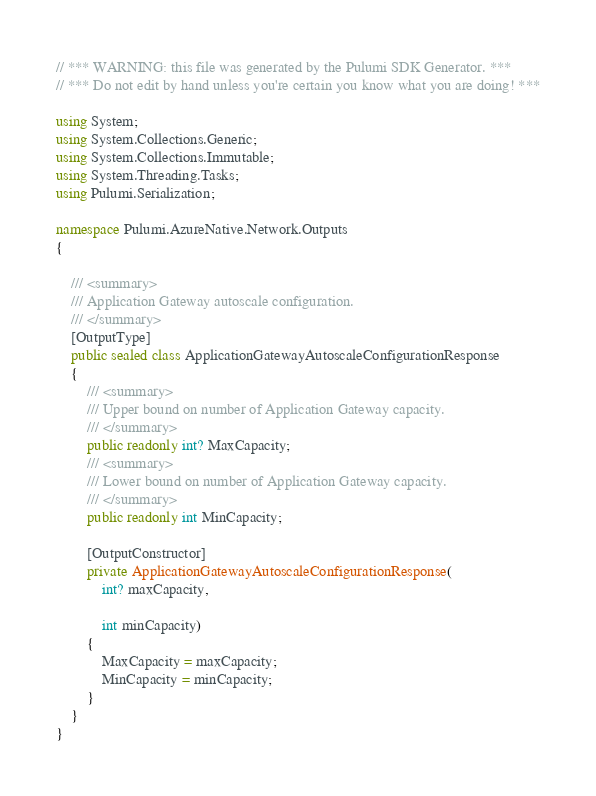Convert code to text. <code><loc_0><loc_0><loc_500><loc_500><_C#_>// *** WARNING: this file was generated by the Pulumi SDK Generator. ***
// *** Do not edit by hand unless you're certain you know what you are doing! ***

using System;
using System.Collections.Generic;
using System.Collections.Immutable;
using System.Threading.Tasks;
using Pulumi.Serialization;

namespace Pulumi.AzureNative.Network.Outputs
{

    /// <summary>
    /// Application Gateway autoscale configuration.
    /// </summary>
    [OutputType]
    public sealed class ApplicationGatewayAutoscaleConfigurationResponse
    {
        /// <summary>
        /// Upper bound on number of Application Gateway capacity.
        /// </summary>
        public readonly int? MaxCapacity;
        /// <summary>
        /// Lower bound on number of Application Gateway capacity.
        /// </summary>
        public readonly int MinCapacity;

        [OutputConstructor]
        private ApplicationGatewayAutoscaleConfigurationResponse(
            int? maxCapacity,

            int minCapacity)
        {
            MaxCapacity = maxCapacity;
            MinCapacity = minCapacity;
        }
    }
}
</code> 